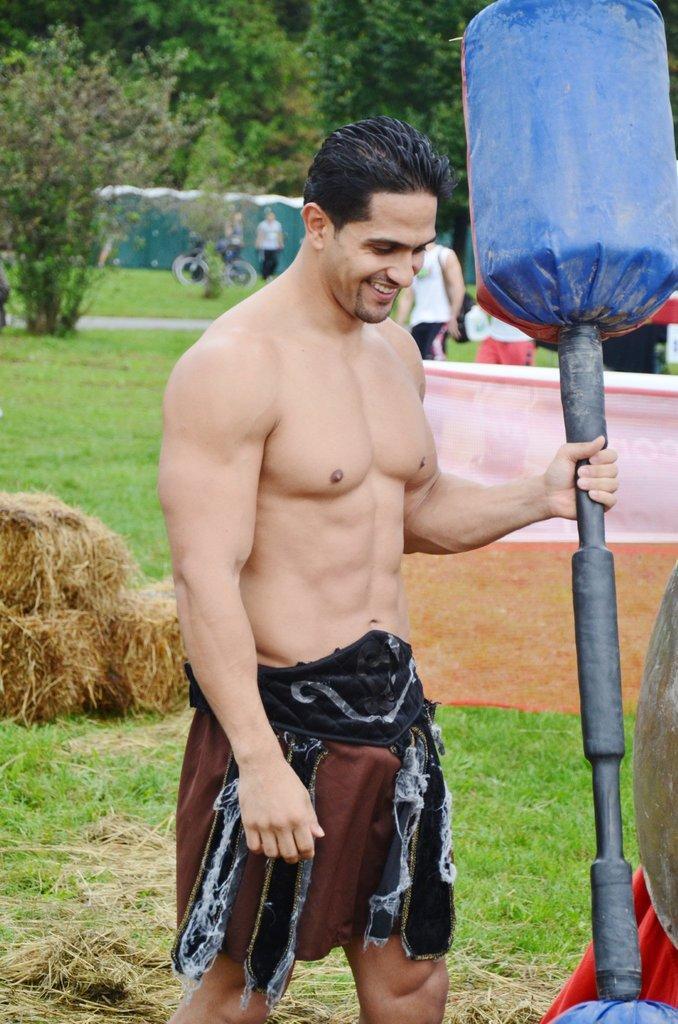How would you summarize this image in a sentence or two? Here we can see a man holding a dumbbell and he is smiling. This is grass and there are plants. In the background we can see few persons and trees. 